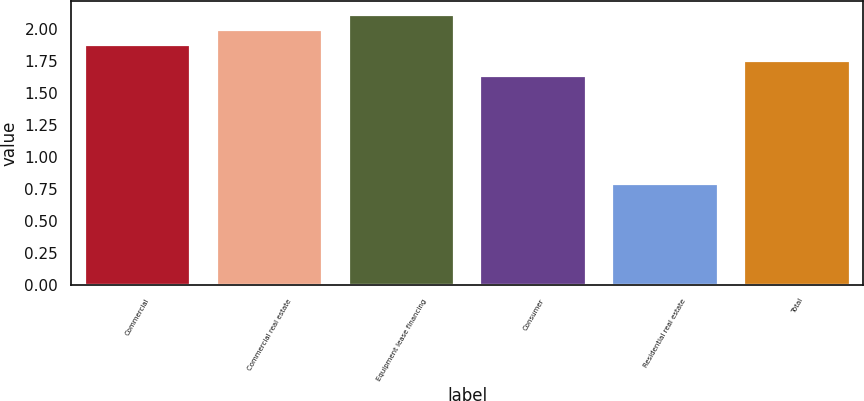Convert chart. <chart><loc_0><loc_0><loc_500><loc_500><bar_chart><fcel>Commercial<fcel>Commercial real estate<fcel>Equipment lease financing<fcel>Consumer<fcel>Residential real estate<fcel>Total<nl><fcel>1.87<fcel>1.99<fcel>2.11<fcel>1.63<fcel>0.79<fcel>1.75<nl></chart> 